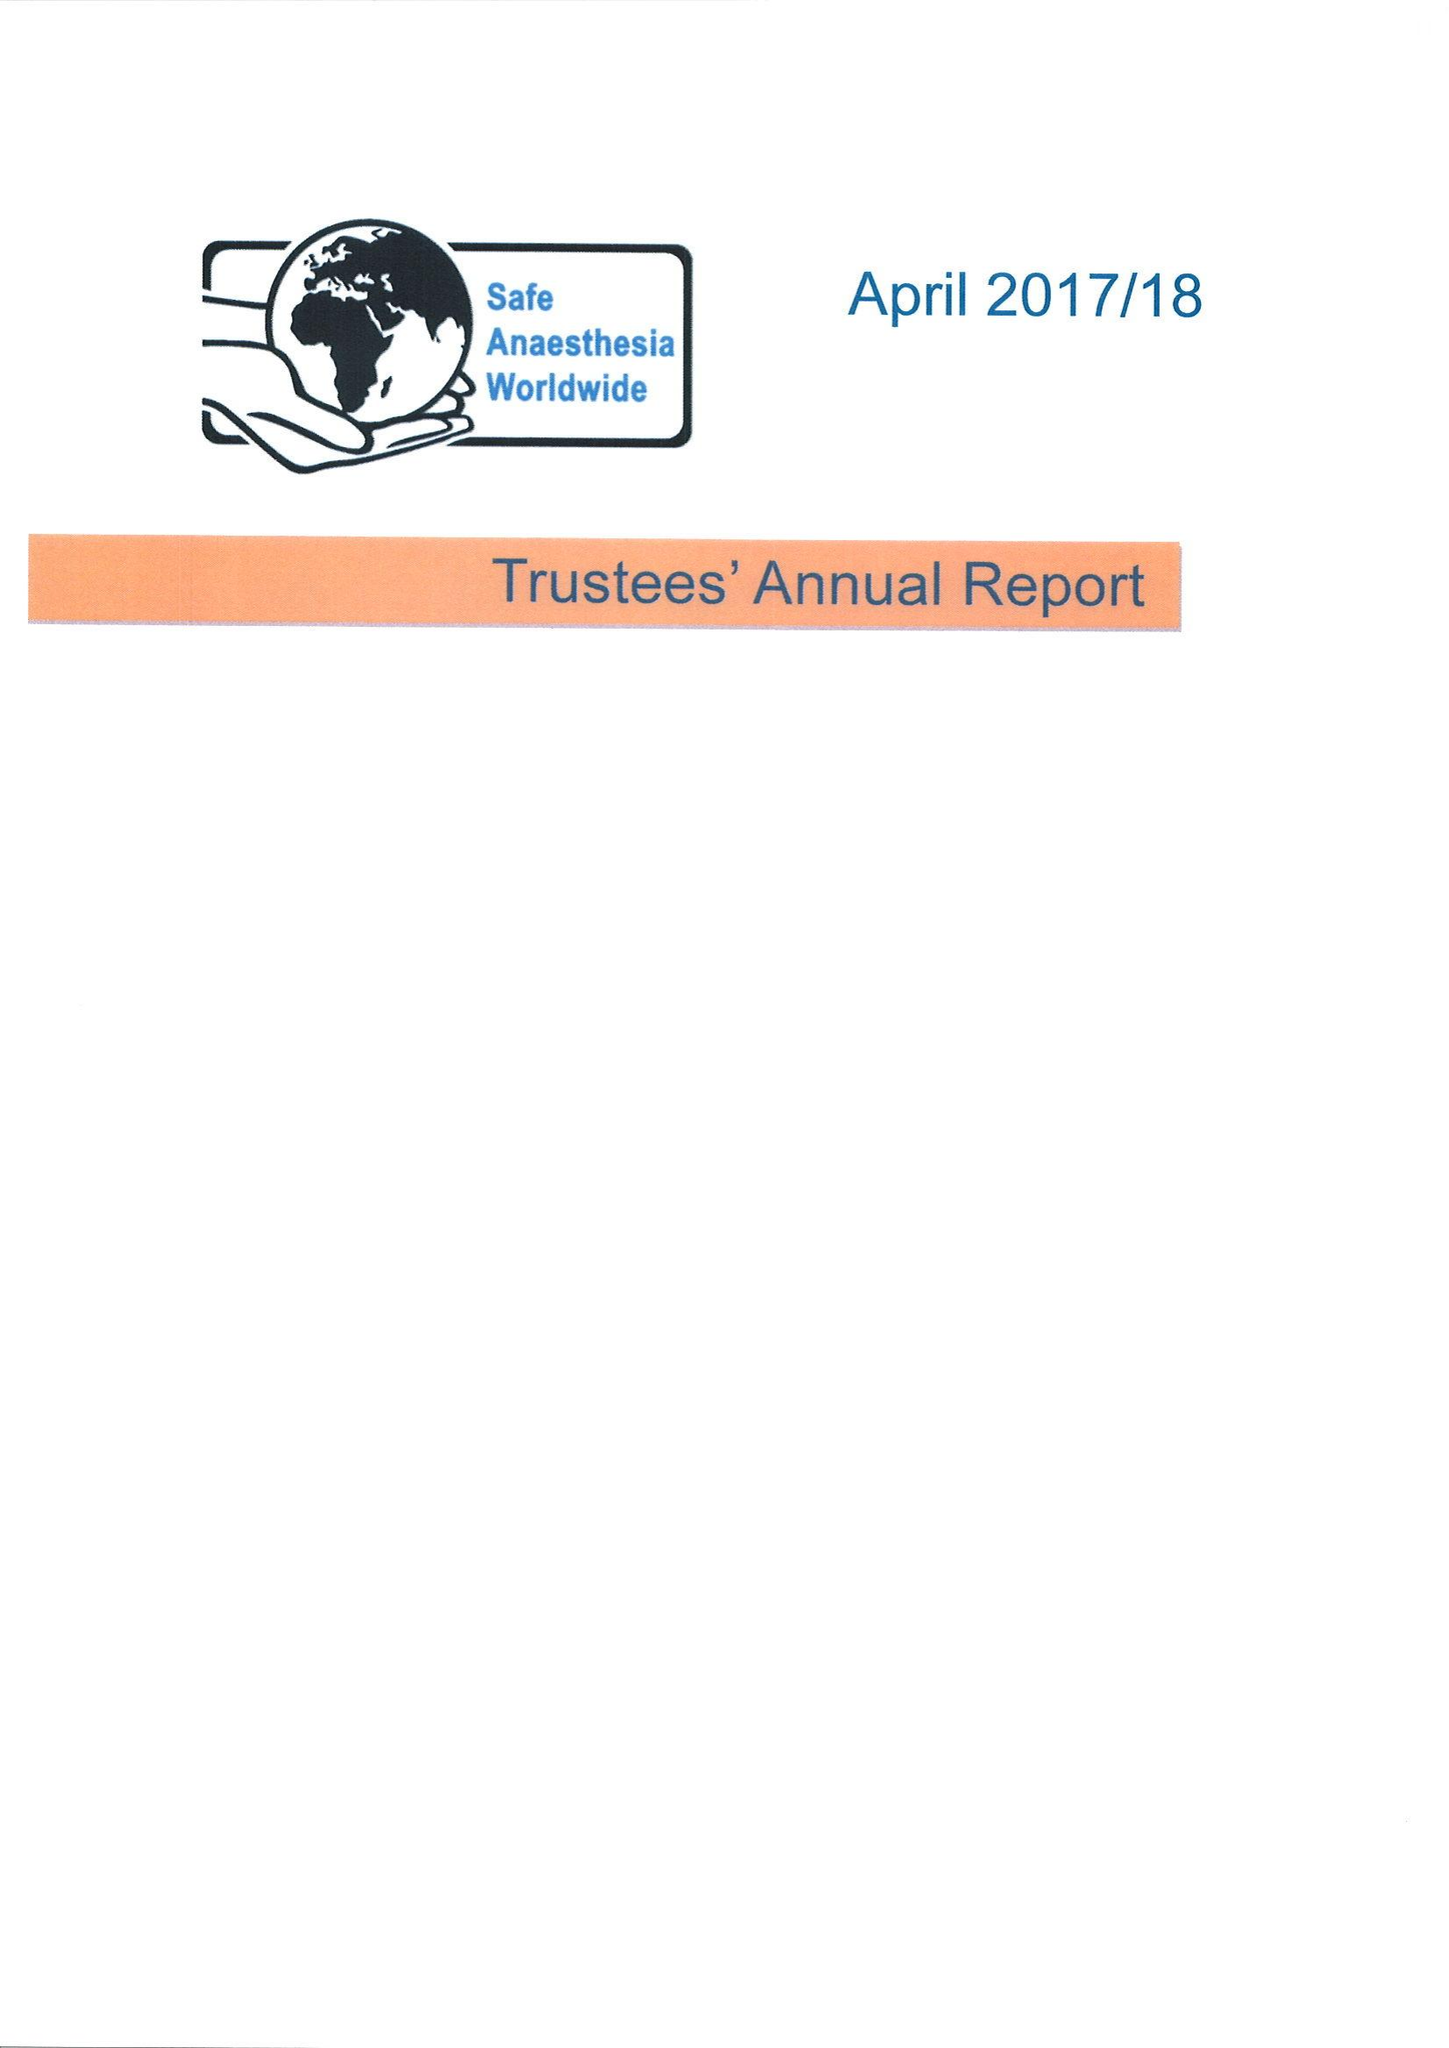What is the value for the charity_name?
Answer the question using a single word or phrase. Safe Anaesthesia Worldwide 